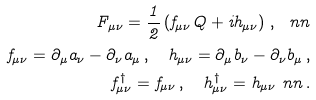<formula> <loc_0><loc_0><loc_500><loc_500>F _ { \mu \nu } = \frac { 1 } { 2 } \left ( f _ { \mu \nu } Q + i h _ { \mu \nu } \right ) \, , \ n n \\ f _ { \mu \nu } = \partial _ { \mu } a _ { \nu } - \partial _ { \nu } a _ { \mu } \, , \quad h _ { \mu \nu } = \partial _ { \mu } b _ { \nu } - \partial _ { \nu } b _ { \mu } \, , \\ f _ { \mu \nu } ^ { \dagger } = f _ { \mu \nu } \, , \quad h _ { \mu \nu } ^ { \dagger } = h _ { \mu \nu } \ n n \, .</formula> 